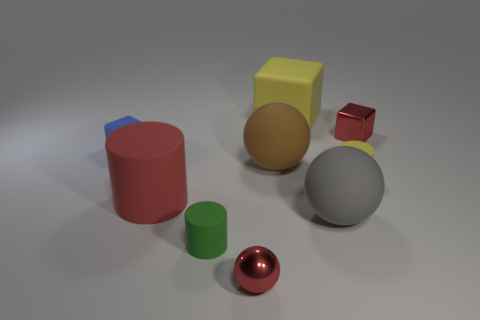Which objects in this image can roll? The red shiny sphere and the large metallic sphere are the two objects that can roll due to their round shapes. 